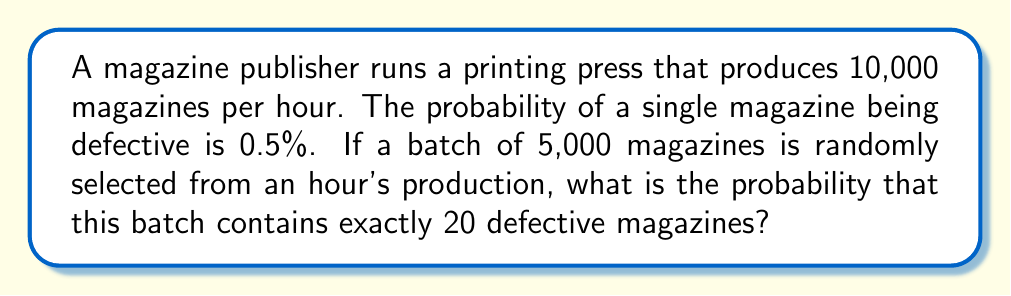Provide a solution to this math problem. To solve this problem, we can use the Binomial probability distribution, as we have a fixed number of independent trials (magazines) with two possible outcomes (defective or not defective) and a constant probability of success (being defective).

Let's define our variables:
$n = 5000$ (number of magazines in the batch)
$p = 0.005$ (probability of a single magazine being defective)
$k = 20$ (number of defective magazines we're looking for)

The probability mass function for the Binomial distribution is:

$$ P(X = k) = \binom{n}{k} p^k (1-p)^{n-k} $$

Where $\binom{n}{k}$ is the binomial coefficient, calculated as:

$$ \binom{n}{k} = \frac{n!}{k!(n-k)!} $$

Let's calculate step by step:

1) First, calculate the binomial coefficient:
   $\binom{5000}{20} = \frac{5000!}{20!(5000-20)!} = \frac{5000!}{20!4980!}$

2) Now, let's plug everything into our probability mass function:

   $$ P(X = 20) = \binom{5000}{20} (0.005)^{20} (1-0.005)^{5000-20} $$

3) Simplify:
   $$ P(X = 20) = \frac{5000!}{20!4980!} (0.005)^{20} (0.995)^{4980} $$

4) Use a calculator or computer to evaluate this expression:

   $P(X = 20) \approx 0.0516$ or about 5.16%

Therefore, the probability of having exactly 20 defective magazines in a batch of 5,000 is approximately 0.0516 or 5.16%.
Answer: $0.0516$ or $5.16\%$ 